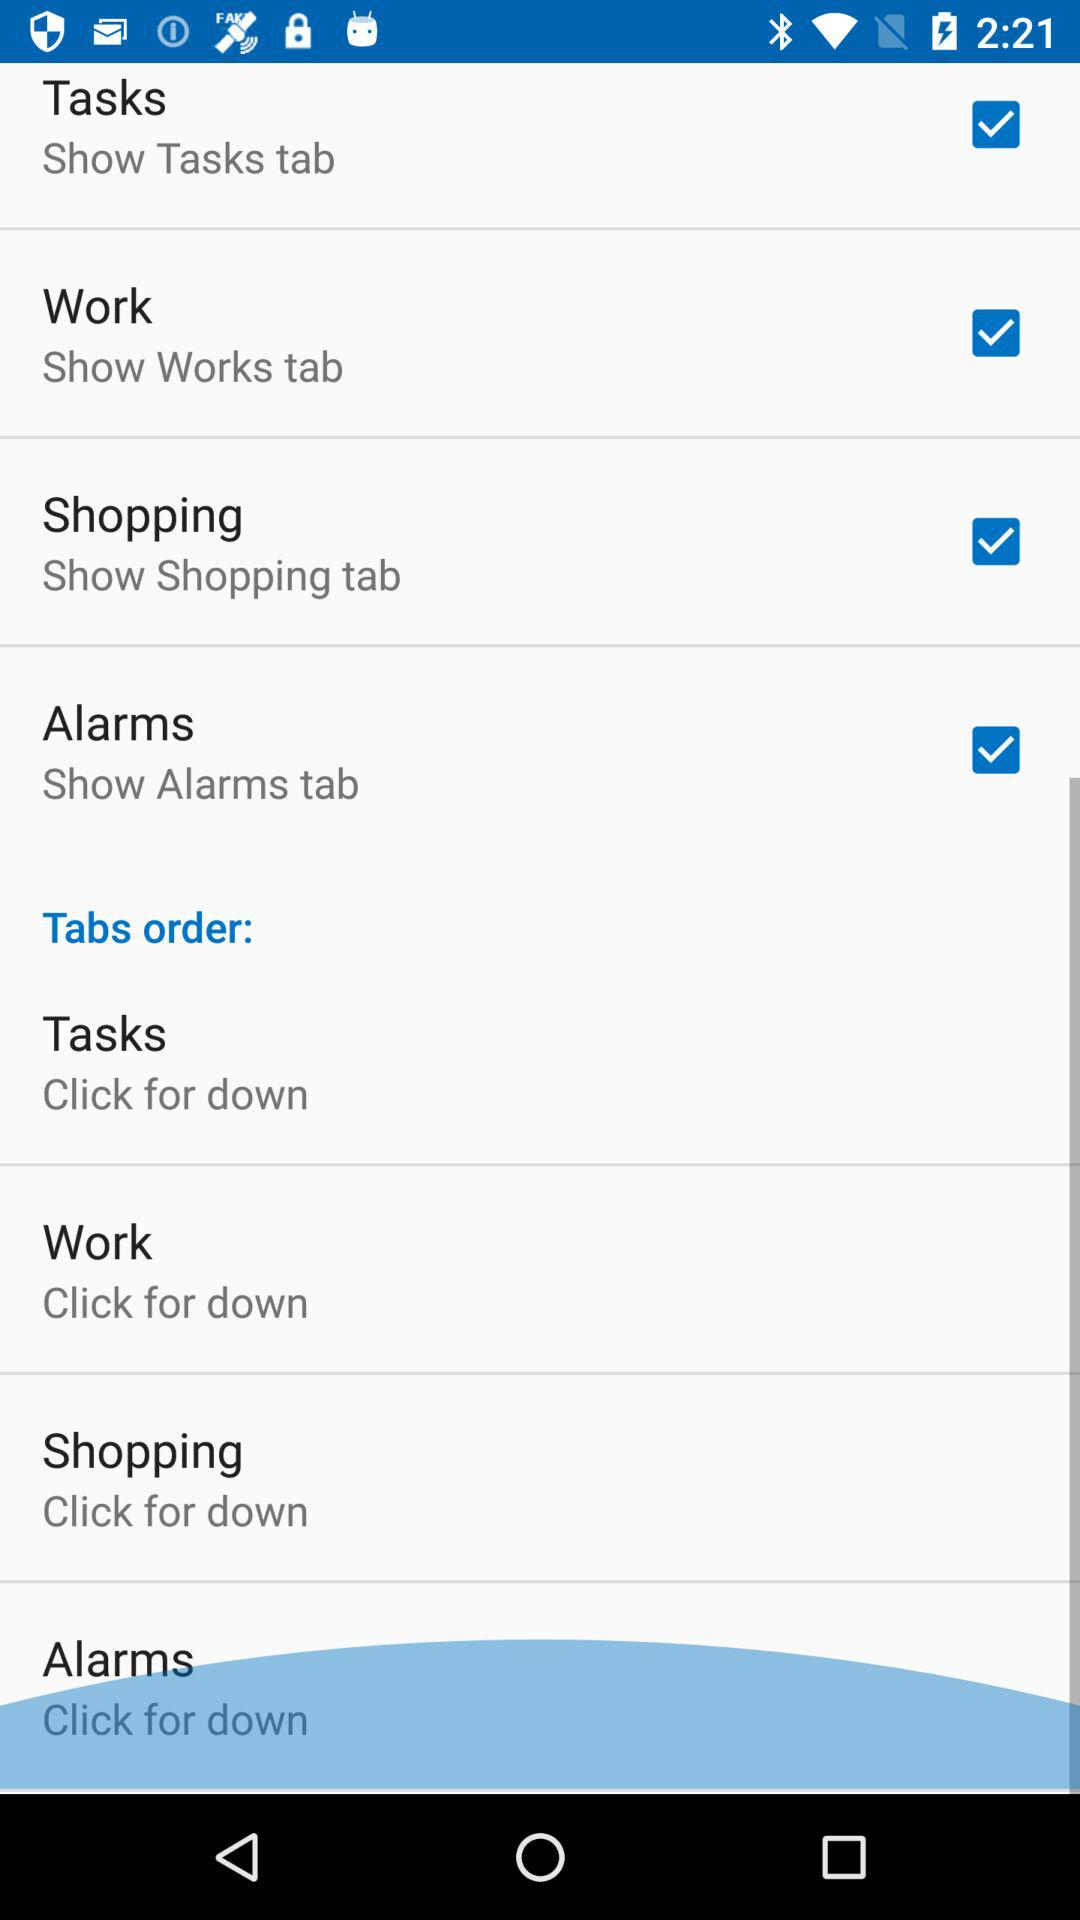What is the current status of shopping? The current status is "on". 